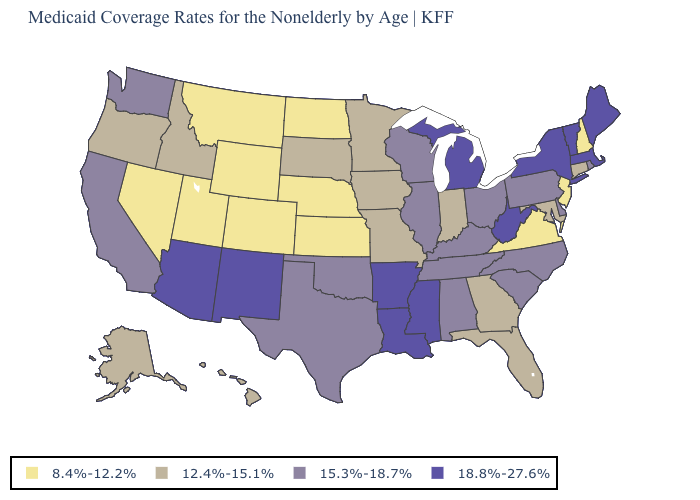Name the states that have a value in the range 15.3%-18.7%?
Quick response, please. Alabama, California, Delaware, Illinois, Kentucky, North Carolina, Ohio, Oklahoma, Pennsylvania, Rhode Island, South Carolina, Tennessee, Texas, Washington, Wisconsin. What is the value of Hawaii?
Be succinct. 12.4%-15.1%. How many symbols are there in the legend?
Concise answer only. 4. Does Alaska have a lower value than Vermont?
Be succinct. Yes. Name the states that have a value in the range 8.4%-12.2%?
Concise answer only. Colorado, Kansas, Montana, Nebraska, Nevada, New Hampshire, New Jersey, North Dakota, Utah, Virginia, Wyoming. What is the value of South Dakota?
Give a very brief answer. 12.4%-15.1%. Among the states that border Iowa , does Illinois have the highest value?
Quick response, please. Yes. Which states have the lowest value in the South?
Short answer required. Virginia. Name the states that have a value in the range 12.4%-15.1%?
Write a very short answer. Alaska, Connecticut, Florida, Georgia, Hawaii, Idaho, Indiana, Iowa, Maryland, Minnesota, Missouri, Oregon, South Dakota. Does Rhode Island have a lower value than Massachusetts?
Answer briefly. Yes. What is the highest value in the West ?
Concise answer only. 18.8%-27.6%. Name the states that have a value in the range 8.4%-12.2%?
Keep it brief. Colorado, Kansas, Montana, Nebraska, Nevada, New Hampshire, New Jersey, North Dakota, Utah, Virginia, Wyoming. Does Arizona have a higher value than Arkansas?
Short answer required. No. What is the value of Vermont?
Answer briefly. 18.8%-27.6%. Which states have the lowest value in the West?
Give a very brief answer. Colorado, Montana, Nevada, Utah, Wyoming. 